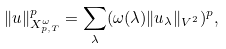Convert formula to latex. <formula><loc_0><loc_0><loc_500><loc_500>\| u \| _ { X ^ { \omega } _ { p , T } } ^ { p } = \sum _ { \lambda } ( \omega ( \lambda ) \| u _ { \lambda } \| _ { V ^ { 2 } } ) ^ { p } ,</formula> 